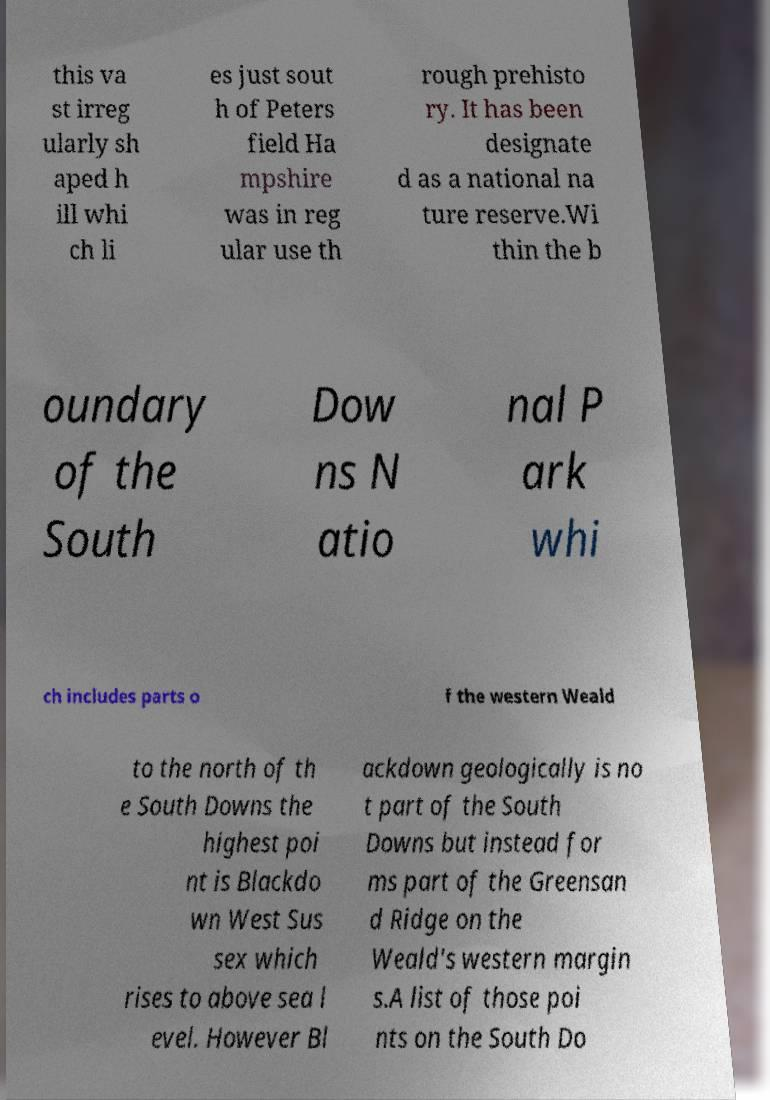Please identify and transcribe the text found in this image. this va st irreg ularly sh aped h ill whi ch li es just sout h of Peters field Ha mpshire was in reg ular use th rough prehisto ry. It has been designate d as a national na ture reserve.Wi thin the b oundary of the South Dow ns N atio nal P ark whi ch includes parts o f the western Weald to the north of th e South Downs the highest poi nt is Blackdo wn West Sus sex which rises to above sea l evel. However Bl ackdown geologically is no t part of the South Downs but instead for ms part of the Greensan d Ridge on the Weald's western margin s.A list of those poi nts on the South Do 